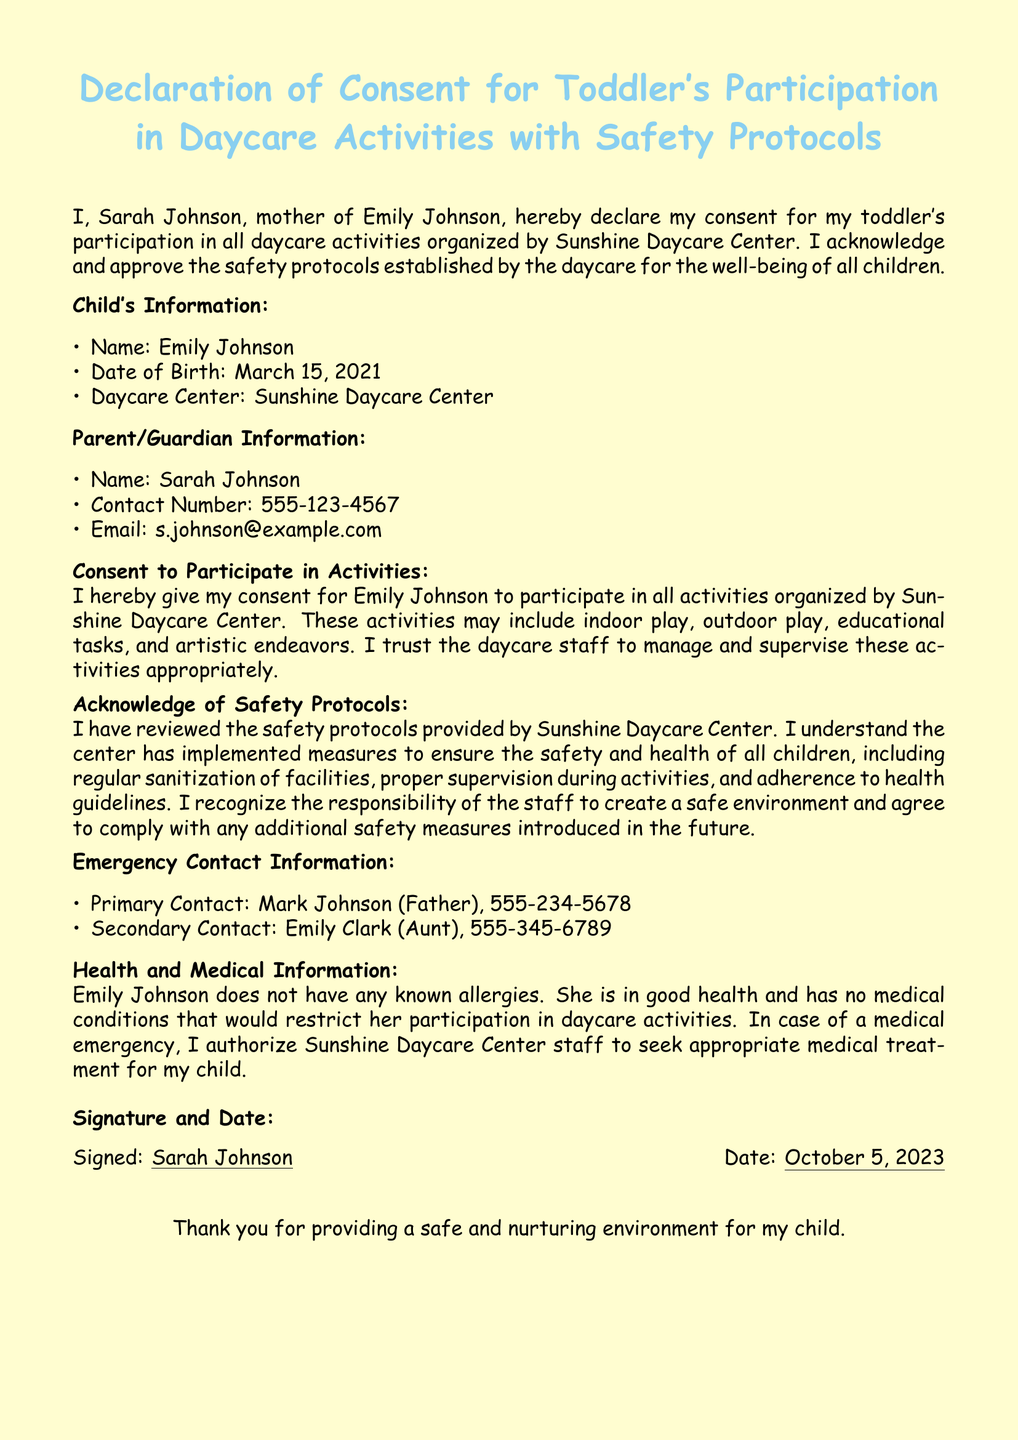What is the child's name? The child's name is mentioned in the Child's Information section of the document, which is Emily Johnson.
Answer: Emily Johnson What is the date of birth of the child? The date of birth is specified in the Child's Information section as March 15, 2021.
Answer: March 15, 2021 Who is the primary emergency contact? The primary emergency contact is listed in the Emergency Contact Information section, which is Mark Johnson (Father).
Answer: Mark Johnson (Father) What safety protocols does the daycare implement? Safety protocols are acknowledged in the document, including regular sanitization, proper supervision, and adherence to health guidelines.
Answer: Regular sanitization, proper supervision, health guidelines Is there any known allergy for the child? The Health and Medical Information section indicates whether there are any allergies or medical conditions that restrict participation.
Answer: No What is the signature date of the document? The date the document was signed is stated near the Signature and Date section, which is October 5, 2023.
Answer: October 5, 2023 What is the mother's contact number? The mother's contact number is clearly outlined in the Parent/Guardian Information section of the document as 555-123-4567.
Answer: 555-123-4567 What daycare center is mentioned? The daycare center name is provided in the Child's Information section, which is Sunshine Daycare Center.
Answer: Sunshine Daycare Center What is the mother's email address? The email address is found in the Parent/Guardian Information section as part of the contact details.
Answer: s.johnson@example.com 